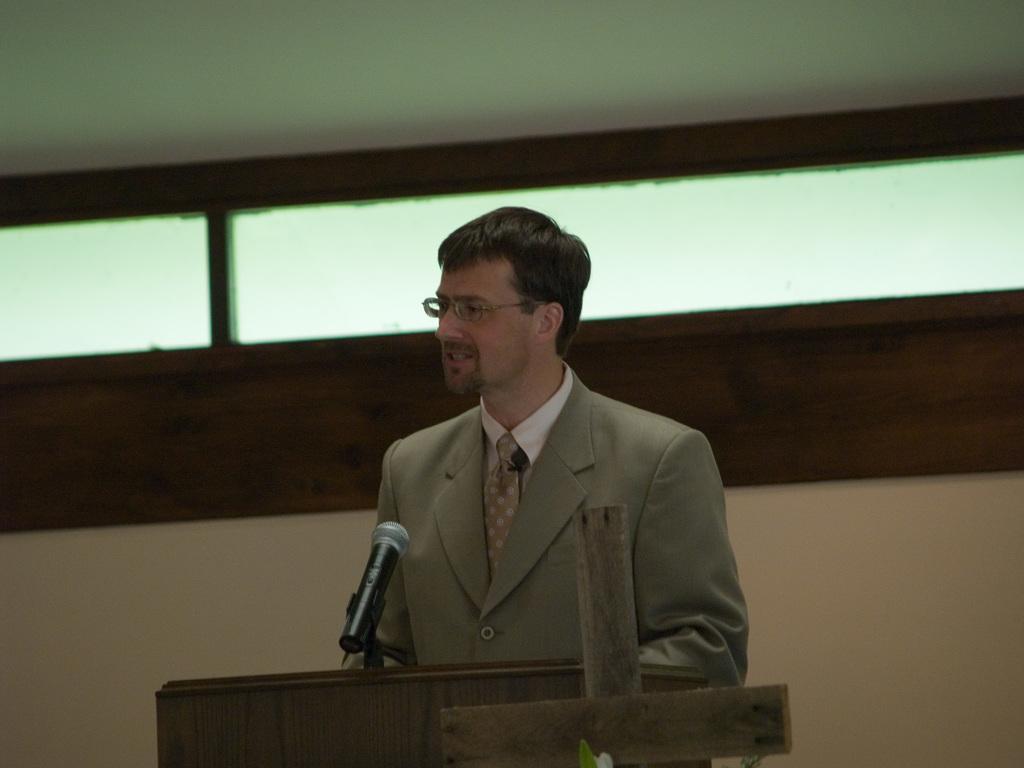In one or two sentences, can you explain what this image depicts? In this picture I can observe a man standing in front of a podium wearing coat and spectacles. There is a mic on the podium. In the background there is a wall. 